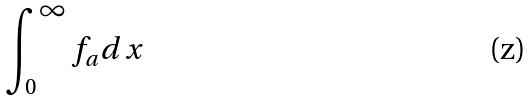<formula> <loc_0><loc_0><loc_500><loc_500>\int _ { 0 } ^ { \infty } f _ { a } d x</formula> 